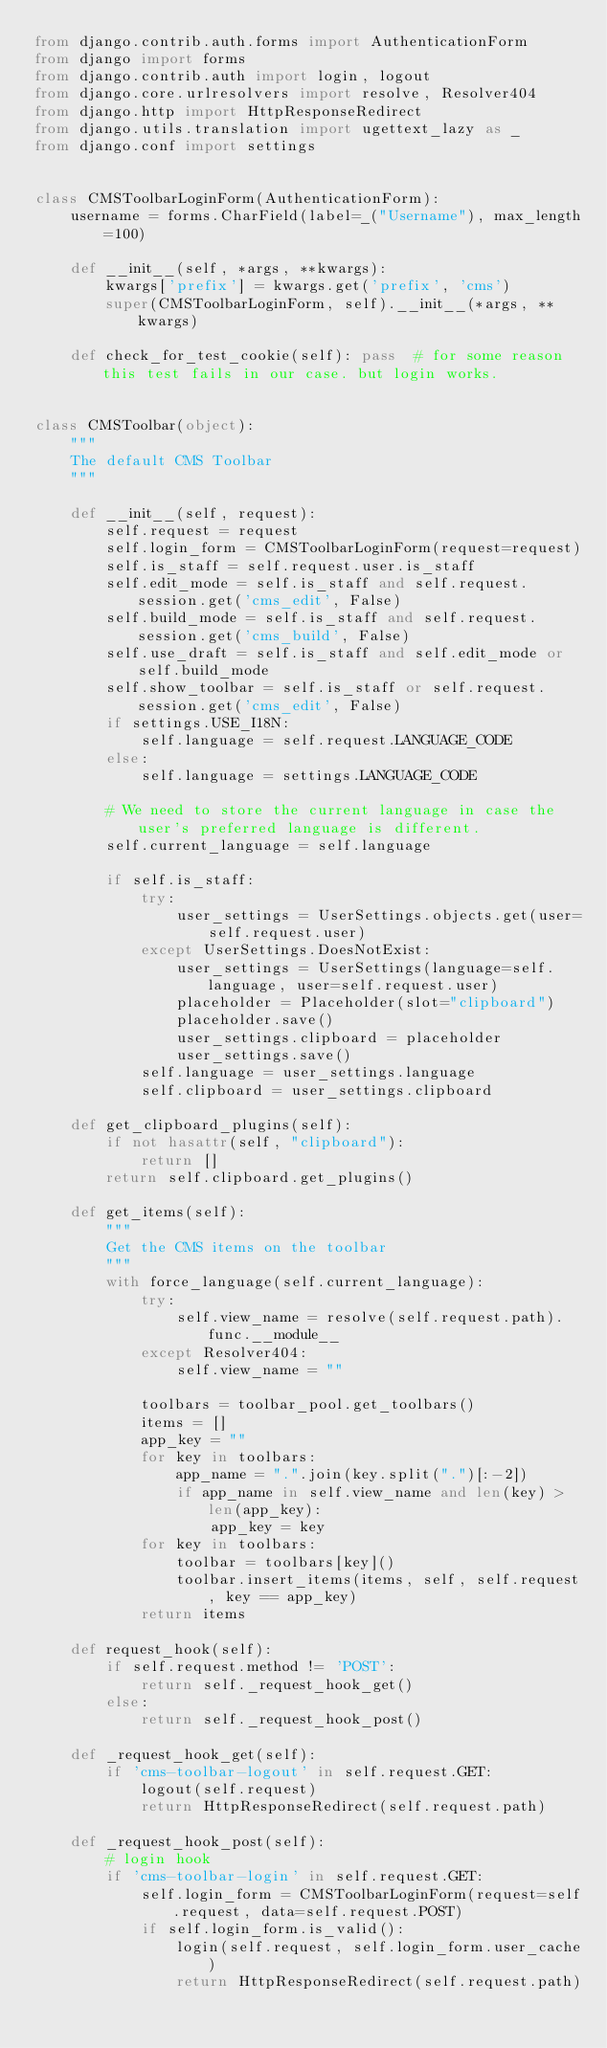Convert code to text. <code><loc_0><loc_0><loc_500><loc_500><_Python_>from django.contrib.auth.forms import AuthenticationForm
from django import forms
from django.contrib.auth import login, logout
from django.core.urlresolvers import resolve, Resolver404
from django.http import HttpResponseRedirect
from django.utils.translation import ugettext_lazy as _
from django.conf import settings


class CMSToolbarLoginForm(AuthenticationForm):
    username = forms.CharField(label=_("Username"), max_length=100)

    def __init__(self, *args, **kwargs):
        kwargs['prefix'] = kwargs.get('prefix', 'cms')
        super(CMSToolbarLoginForm, self).__init__(*args, **kwargs)

    def check_for_test_cookie(self): pass  # for some reason this test fails in our case. but login works.


class CMSToolbar(object):
    """
    The default CMS Toolbar
    """

    def __init__(self, request):
        self.request = request
        self.login_form = CMSToolbarLoginForm(request=request)
        self.is_staff = self.request.user.is_staff
        self.edit_mode = self.is_staff and self.request.session.get('cms_edit', False)
        self.build_mode = self.is_staff and self.request.session.get('cms_build', False)
        self.use_draft = self.is_staff and self.edit_mode or self.build_mode
        self.show_toolbar = self.is_staff or self.request.session.get('cms_edit', False)
        if settings.USE_I18N:
            self.language = self.request.LANGUAGE_CODE
        else:
            self.language = settings.LANGUAGE_CODE

        # We need to store the current language in case the user's preferred language is different.
        self.current_language = self.language

        if self.is_staff:
            try:
                user_settings = UserSettings.objects.get(user=self.request.user)
            except UserSettings.DoesNotExist:
                user_settings = UserSettings(language=self.language, user=self.request.user)
                placeholder = Placeholder(slot="clipboard")
                placeholder.save()
                user_settings.clipboard = placeholder
                user_settings.save()
            self.language = user_settings.language
            self.clipboard = user_settings.clipboard

    def get_clipboard_plugins(self):
        if not hasattr(self, "clipboard"):
            return []
        return self.clipboard.get_plugins()

    def get_items(self):
        """
        Get the CMS items on the toolbar
        """
        with force_language(self.current_language):
            try:
                self.view_name = resolve(self.request.path).func.__module__
            except Resolver404:
                self.view_name = ""
       
            toolbars = toolbar_pool.get_toolbars()
            items = []
            app_key = ""
            for key in toolbars:
                app_name = ".".join(key.split(".")[:-2])
                if app_name in self.view_name and len(key) > len(app_key):
                    app_key = key
            for key in toolbars:
                toolbar = toolbars[key]()
                toolbar.insert_items(items, self, self.request, key == app_key)
            return items

    def request_hook(self):
        if self.request.method != 'POST':
            return self._request_hook_get()
        else:
            return self._request_hook_post()

    def _request_hook_get(self):
        if 'cms-toolbar-logout' in self.request.GET:
            logout(self.request)
            return HttpResponseRedirect(self.request.path)

    def _request_hook_post(self):
        # login hook
        if 'cms-toolbar-login' in self.request.GET:
            self.login_form = CMSToolbarLoginForm(request=self.request, data=self.request.POST)
            if self.login_form.is_valid():
                login(self.request, self.login_form.user_cache)
                return HttpResponseRedirect(self.request.path)
</code> 